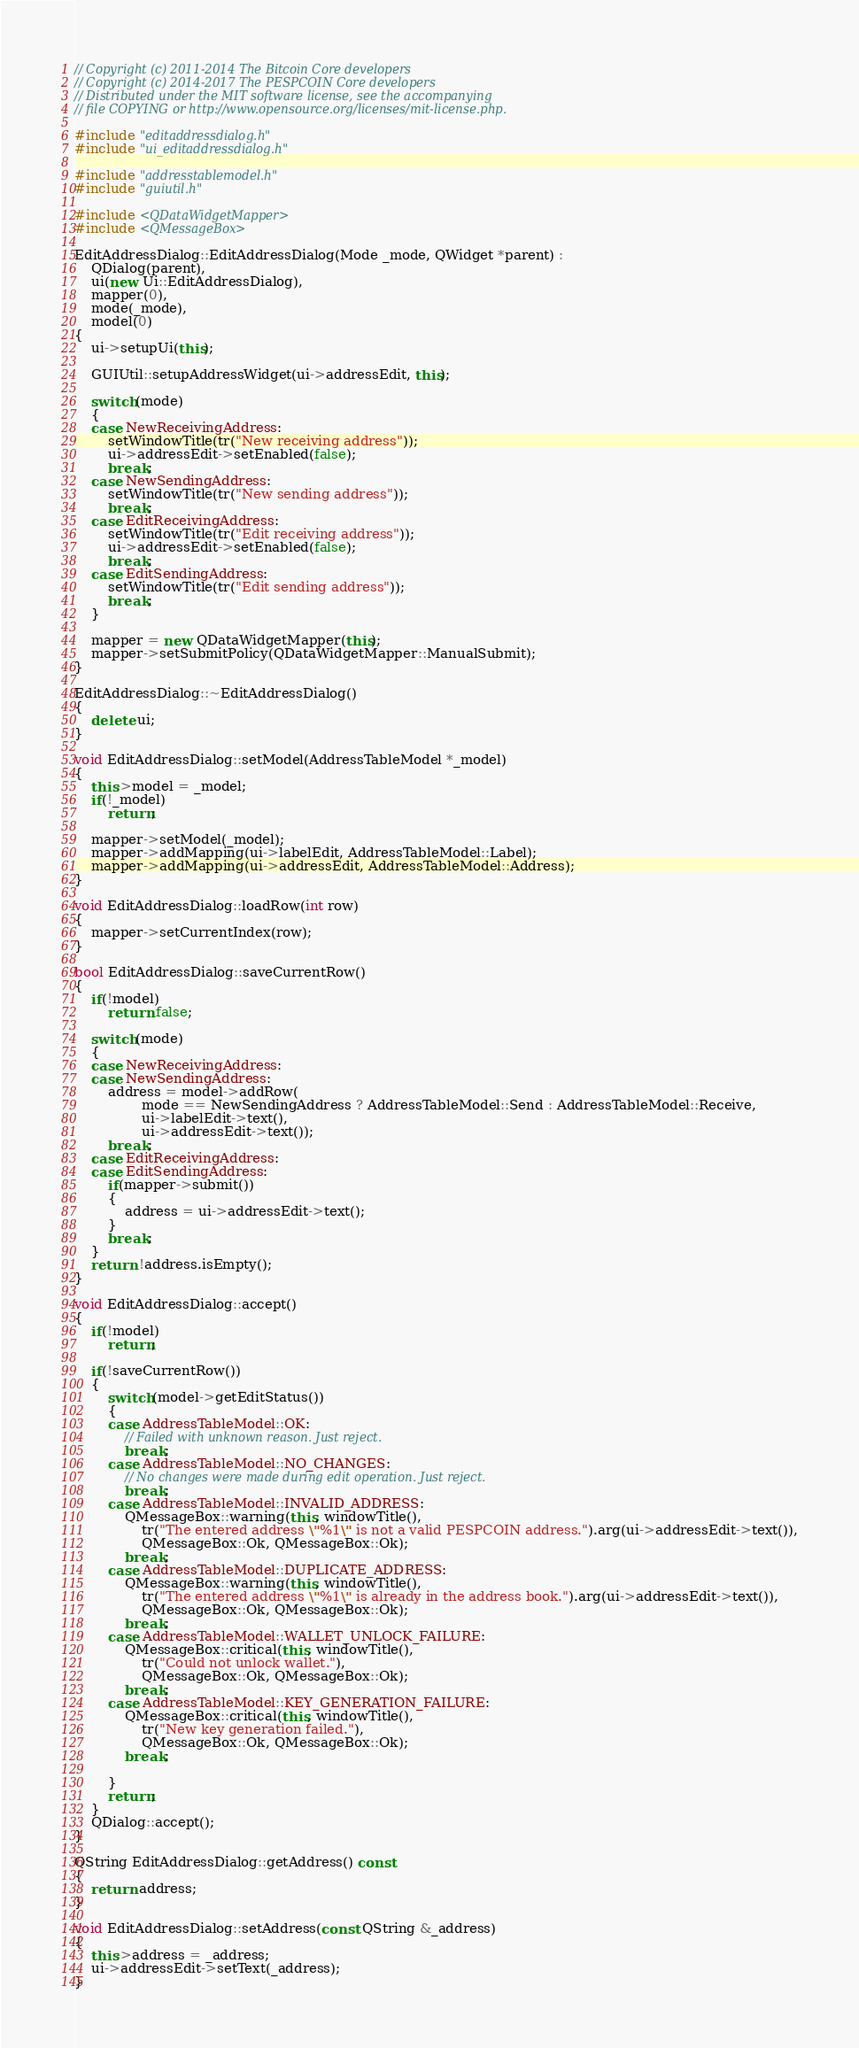Convert code to text. <code><loc_0><loc_0><loc_500><loc_500><_C++_>// Copyright (c) 2011-2014 The Bitcoin Core developers
// Copyright (c) 2014-2017 The PESPCOIN Core developers
// Distributed under the MIT software license, see the accompanying
// file COPYING or http://www.opensource.org/licenses/mit-license.php.

#include "editaddressdialog.h"
#include "ui_editaddressdialog.h"

#include "addresstablemodel.h"
#include "guiutil.h"

#include <QDataWidgetMapper>
#include <QMessageBox>

EditAddressDialog::EditAddressDialog(Mode _mode, QWidget *parent) :
    QDialog(parent),
    ui(new Ui::EditAddressDialog),
    mapper(0),
    mode(_mode),
    model(0)
{
    ui->setupUi(this);

    GUIUtil::setupAddressWidget(ui->addressEdit, this);

    switch(mode)
    {
    case NewReceivingAddress:
        setWindowTitle(tr("New receiving address"));
        ui->addressEdit->setEnabled(false);
        break;
    case NewSendingAddress:
        setWindowTitle(tr("New sending address"));
        break;
    case EditReceivingAddress:
        setWindowTitle(tr("Edit receiving address"));
        ui->addressEdit->setEnabled(false);
        break;
    case EditSendingAddress:
        setWindowTitle(tr("Edit sending address"));
        break;
    }

    mapper = new QDataWidgetMapper(this);
    mapper->setSubmitPolicy(QDataWidgetMapper::ManualSubmit);
}

EditAddressDialog::~EditAddressDialog()
{
    delete ui;
}

void EditAddressDialog::setModel(AddressTableModel *_model)
{
    this->model = _model;
    if(!_model)
        return;

    mapper->setModel(_model);
    mapper->addMapping(ui->labelEdit, AddressTableModel::Label);
    mapper->addMapping(ui->addressEdit, AddressTableModel::Address);
}

void EditAddressDialog::loadRow(int row)
{
    mapper->setCurrentIndex(row);
}

bool EditAddressDialog::saveCurrentRow()
{
    if(!model)
        return false;

    switch(mode)
    {
    case NewReceivingAddress:
    case NewSendingAddress:
        address = model->addRow(
                mode == NewSendingAddress ? AddressTableModel::Send : AddressTableModel::Receive,
                ui->labelEdit->text(),
                ui->addressEdit->text());
        break;
    case EditReceivingAddress:
    case EditSendingAddress:
        if(mapper->submit())
        {
            address = ui->addressEdit->text();
        }
        break;
    }
    return !address.isEmpty();
}

void EditAddressDialog::accept()
{
    if(!model)
        return;

    if(!saveCurrentRow())
    {
        switch(model->getEditStatus())
        {
        case AddressTableModel::OK:
            // Failed with unknown reason. Just reject.
            break;
        case AddressTableModel::NO_CHANGES:
            // No changes were made during edit operation. Just reject.
            break;
        case AddressTableModel::INVALID_ADDRESS:
            QMessageBox::warning(this, windowTitle(),
                tr("The entered address \"%1\" is not a valid PESPCOIN address.").arg(ui->addressEdit->text()),
                QMessageBox::Ok, QMessageBox::Ok);
            break;
        case AddressTableModel::DUPLICATE_ADDRESS:
            QMessageBox::warning(this, windowTitle(),
                tr("The entered address \"%1\" is already in the address book.").arg(ui->addressEdit->text()),
                QMessageBox::Ok, QMessageBox::Ok);
            break;
        case AddressTableModel::WALLET_UNLOCK_FAILURE:
            QMessageBox::critical(this, windowTitle(),
                tr("Could not unlock wallet."),
                QMessageBox::Ok, QMessageBox::Ok);
            break;
        case AddressTableModel::KEY_GENERATION_FAILURE:
            QMessageBox::critical(this, windowTitle(),
                tr("New key generation failed."),
                QMessageBox::Ok, QMessageBox::Ok);
            break;

        }
        return;
    }
    QDialog::accept();
}

QString EditAddressDialog::getAddress() const
{
    return address;
}

void EditAddressDialog::setAddress(const QString &_address)
{
    this->address = _address;
    ui->addressEdit->setText(_address);
}
</code> 